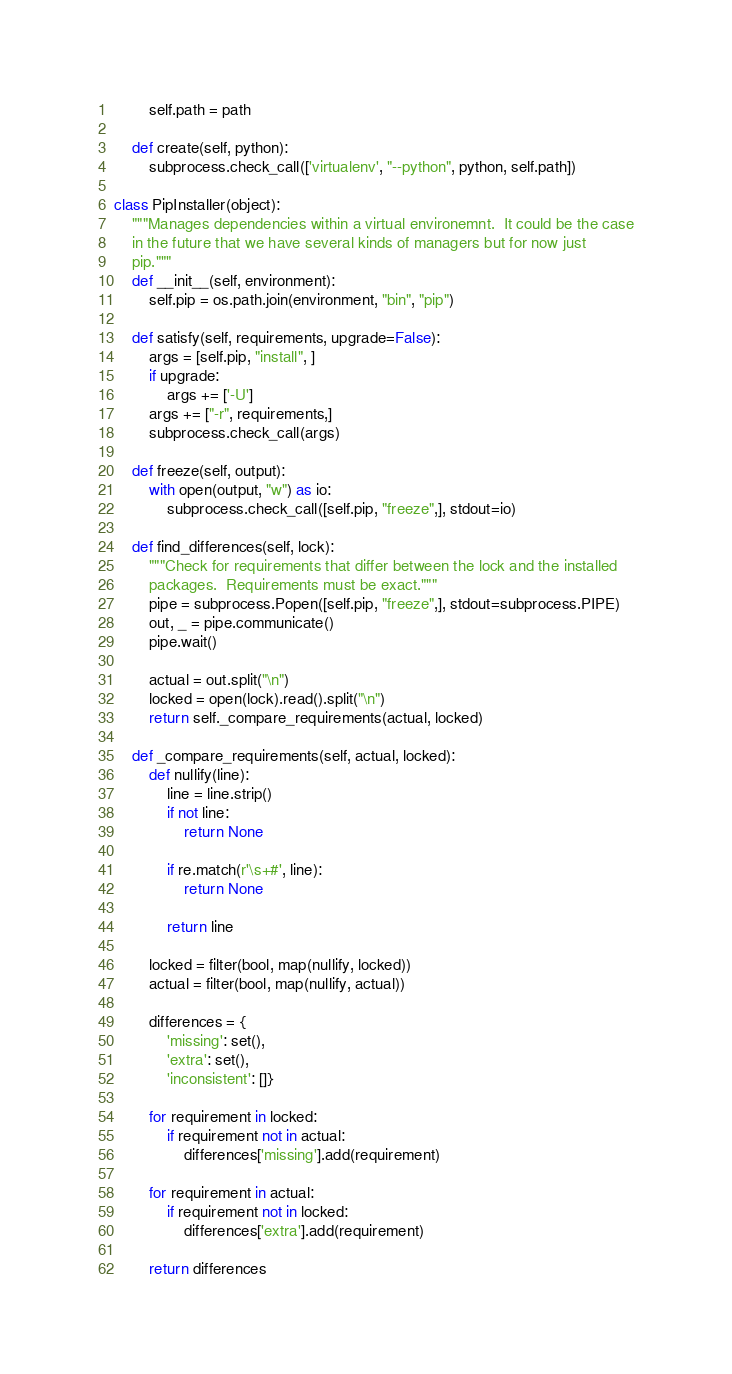Convert code to text. <code><loc_0><loc_0><loc_500><loc_500><_Python_>        self.path = path

    def create(self, python):
        subprocess.check_call(['virtualenv', "--python", python, self.path])

class PipInstaller(object):
    """Manages dependencies within a virtual environemnt.  It could be the case
    in the future that we have several kinds of managers but for now just
    pip."""
    def __init__(self, environment):
        self.pip = os.path.join(environment, "bin", "pip")

    def satisfy(self, requirements, upgrade=False):
        args = [self.pip, "install", ]
        if upgrade:
            args += ['-U']
        args += ["-r", requirements,]
        subprocess.check_call(args)

    def freeze(self, output):
        with open(output, "w") as io:
            subprocess.check_call([self.pip, "freeze",], stdout=io)

    def find_differences(self, lock):
        """Check for requirements that differ between the lock and the installed
        packages.  Requirements must be exact."""
        pipe = subprocess.Popen([self.pip, "freeze",], stdout=subprocess.PIPE)
        out, _ = pipe.communicate()
        pipe.wait()

        actual = out.split("\n")
        locked = open(lock).read().split("\n")
        return self._compare_requirements(actual, locked)

    def _compare_requirements(self, actual, locked):
        def nullify(line):
            line = line.strip()
            if not line:
                return None

            if re.match(r'\s+#', line):
                return None

            return line

        locked = filter(bool, map(nullify, locked))
        actual = filter(bool, map(nullify, actual))

        differences = {
            'missing': set(),
            'extra': set(),
            'inconsistent': []}

        for requirement in locked:
            if requirement not in actual:
                differences['missing'].add(requirement)

        for requirement in actual:
            if requirement not in locked:
                differences['extra'].add(requirement)

        return differences
</code> 